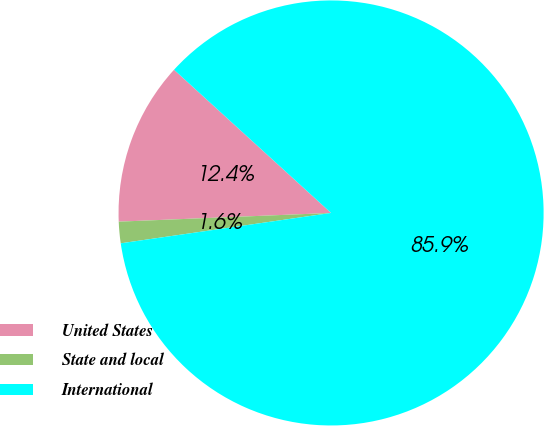Convert chart to OTSL. <chart><loc_0><loc_0><loc_500><loc_500><pie_chart><fcel>United States<fcel>State and local<fcel>International<nl><fcel>12.42%<fcel>1.63%<fcel>85.95%<nl></chart> 